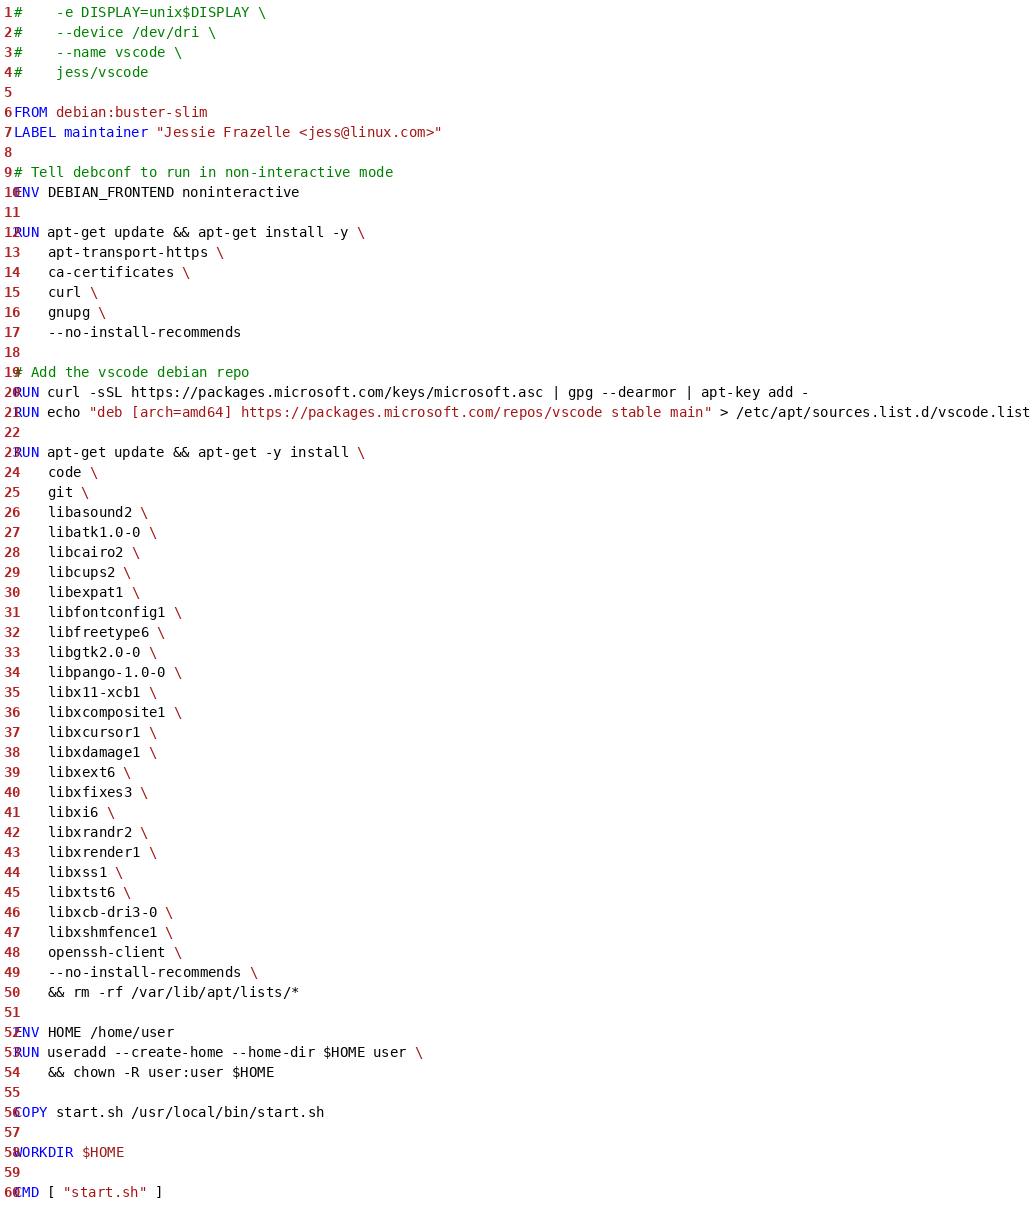<code> <loc_0><loc_0><loc_500><loc_500><_Dockerfile_>#    -e DISPLAY=unix$DISPLAY \
#    --device /dev/dri \
#    --name vscode \
#    jess/vscode

FROM debian:buster-slim
LABEL maintainer "Jessie Frazelle <jess@linux.com>"

# Tell debconf to run in non-interactive mode
ENV DEBIAN_FRONTEND noninteractive

RUN apt-get update && apt-get install -y \
	apt-transport-https \
	ca-certificates \
	curl \
	gnupg \
	--no-install-recommends

# Add the vscode debian repo
RUN curl -sSL https://packages.microsoft.com/keys/microsoft.asc | gpg --dearmor | apt-key add -
RUN echo "deb [arch=amd64] https://packages.microsoft.com/repos/vscode stable main" > /etc/apt/sources.list.d/vscode.list

RUN apt-get update && apt-get -y install \
	code \
	git \
	libasound2 \
	libatk1.0-0 \
	libcairo2 \
	libcups2 \
	libexpat1 \
	libfontconfig1 \
	libfreetype6 \
	libgtk2.0-0 \
	libpango-1.0-0 \
	libx11-xcb1 \
	libxcomposite1 \
	libxcursor1 \
	libxdamage1 \
	libxext6 \
	libxfixes3 \
	libxi6 \
	libxrandr2 \
	libxrender1 \
	libxss1 \
	libxtst6 \
	libxcb-dri3-0 \
    libxshmfence1 \
    openssh-client \
	--no-install-recommends \
	&& rm -rf /var/lib/apt/lists/*

ENV HOME /home/user
RUN useradd --create-home --home-dir $HOME user \
	&& chown -R user:user $HOME

COPY start.sh /usr/local/bin/start.sh

WORKDIR $HOME

CMD [ "start.sh" ]
</code> 